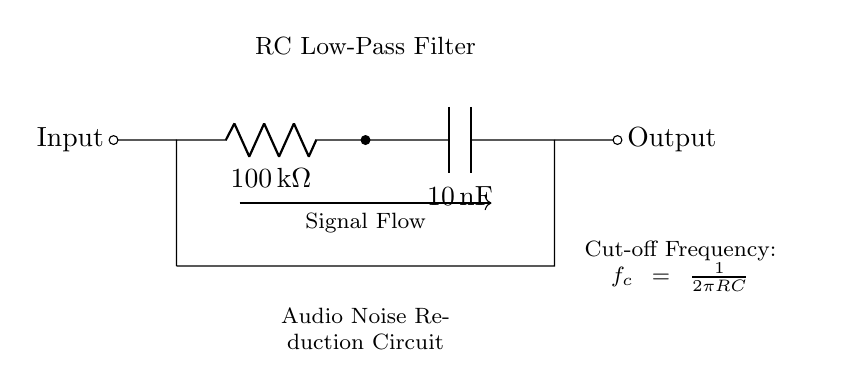What type of filter is represented in this circuit? The circuit is labeled as an "RC Low-Pass Filter," indicating that its primary function is to allow low-frequency signals to pass while attenuating high-frequency signals.
Answer: RC Low-Pass Filter What is the resistance value in this circuit? The resistor is indicated as having a value of "100 kΩ," which is specified alongside the component labeling in the circuit diagram.
Answer: 100 kΩ What is the capacitance value in this circuit? The circuit diagram specifies the capacitor value as "10 nF," which is essential for its filtering characteristics.
Answer: 10 nF What is the cut-off frequency formula used in this RC filter? The cut-off frequency is defined by the equation "fc = 1 / (2 * π * R * C)," which indicates how the filter responds to different frequencies based on its resistance and capacitance values.
Answer: fc = 1 / (2 * π * R * C) What does the arrow in the circuit indicate? The arrow marked as "Signal Flow" indicates the direction in which the input signal travels through the circuit, moving from the left to the right.
Answer: Signal Flow At what point in the circuit does the output signal appear? The output signal is taken from the right side of the circuit at the capacitor, specifically indicated as "Output," revealing where the filtered signal exits the circuit.
Answer: Output How does this RC filter affect high-frequency signals? This RC Low-Pass Filter design emphasizes that high-frequency signals are attenuated, meaning they are reduced in amplitude when passing through the circuit due to the characteristics of the resistor and capacitor.
Answer: Attenuated 